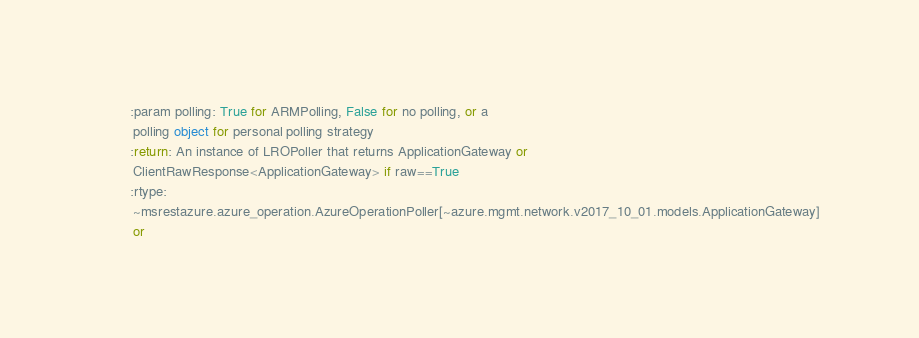Convert code to text. <code><loc_0><loc_0><loc_500><loc_500><_Python_>        :param polling: True for ARMPolling, False for no polling, or a
         polling object for personal polling strategy
        :return: An instance of LROPoller that returns ApplicationGateway or
         ClientRawResponse<ApplicationGateway> if raw==True
        :rtype:
         ~msrestazure.azure_operation.AzureOperationPoller[~azure.mgmt.network.v2017_10_01.models.ApplicationGateway]
         or</code> 